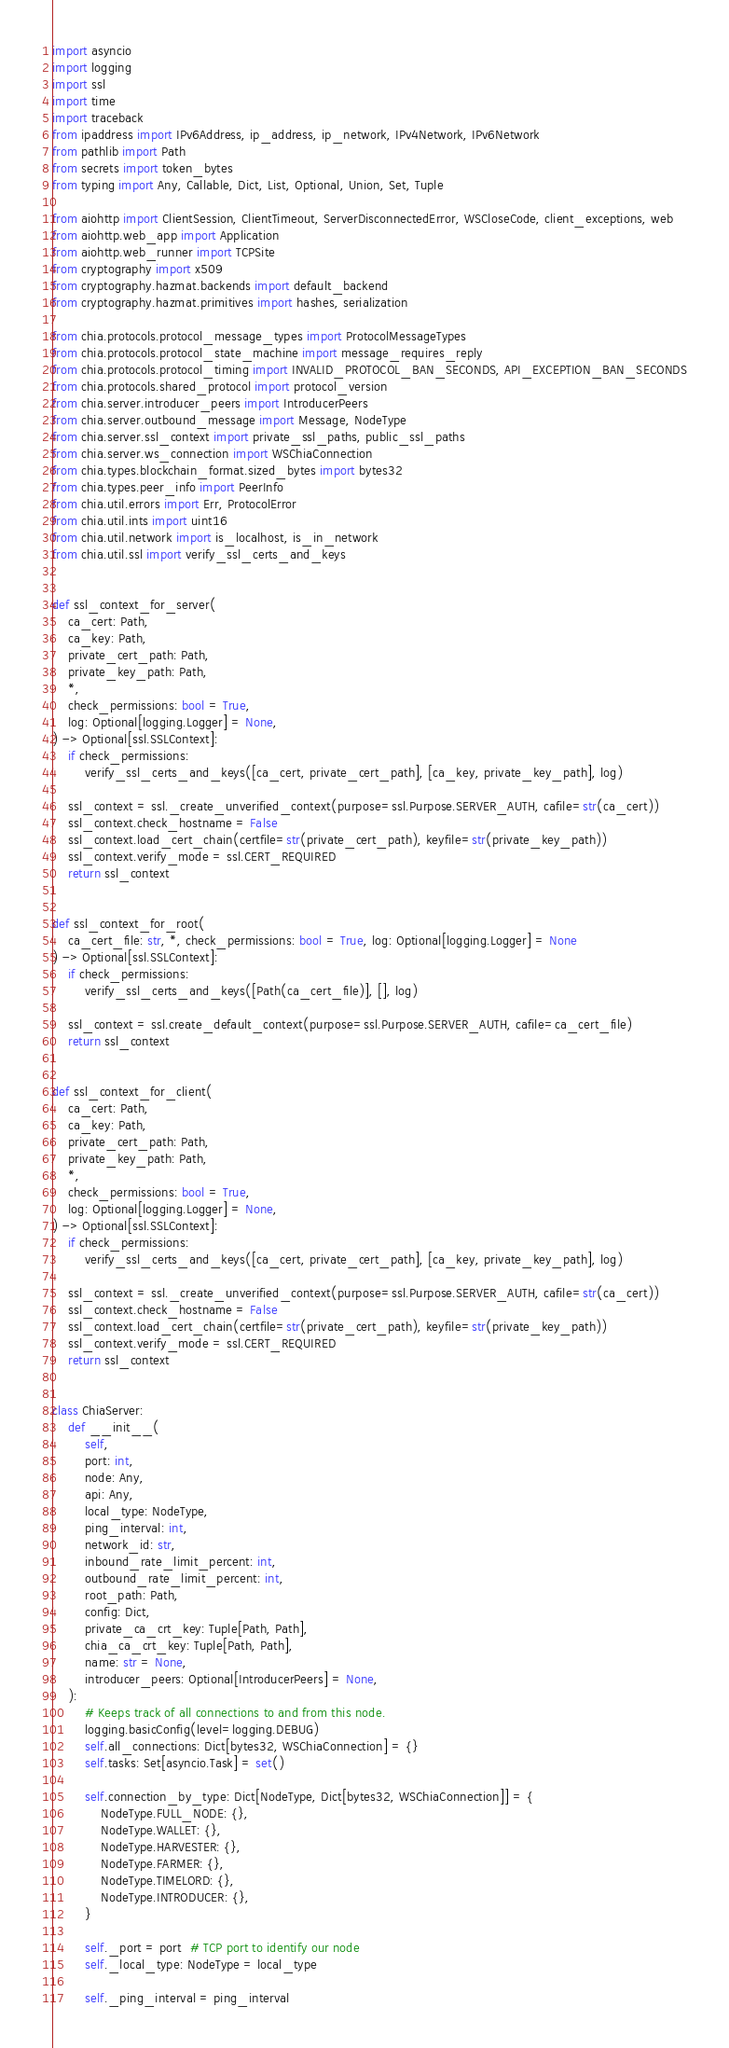<code> <loc_0><loc_0><loc_500><loc_500><_Python_>import asyncio
import logging
import ssl
import time
import traceback
from ipaddress import IPv6Address, ip_address, ip_network, IPv4Network, IPv6Network
from pathlib import Path
from secrets import token_bytes
from typing import Any, Callable, Dict, List, Optional, Union, Set, Tuple

from aiohttp import ClientSession, ClientTimeout, ServerDisconnectedError, WSCloseCode, client_exceptions, web
from aiohttp.web_app import Application
from aiohttp.web_runner import TCPSite
from cryptography import x509
from cryptography.hazmat.backends import default_backend
from cryptography.hazmat.primitives import hashes, serialization

from chia.protocols.protocol_message_types import ProtocolMessageTypes
from chia.protocols.protocol_state_machine import message_requires_reply
from chia.protocols.protocol_timing import INVALID_PROTOCOL_BAN_SECONDS, API_EXCEPTION_BAN_SECONDS
from chia.protocols.shared_protocol import protocol_version
from chia.server.introducer_peers import IntroducerPeers
from chia.server.outbound_message import Message, NodeType
from chia.server.ssl_context import private_ssl_paths, public_ssl_paths
from chia.server.ws_connection import WSChiaConnection
from chia.types.blockchain_format.sized_bytes import bytes32
from chia.types.peer_info import PeerInfo
from chia.util.errors import Err, ProtocolError
from chia.util.ints import uint16
from chia.util.network import is_localhost, is_in_network
from chia.util.ssl import verify_ssl_certs_and_keys


def ssl_context_for_server(
    ca_cert: Path,
    ca_key: Path,
    private_cert_path: Path,
    private_key_path: Path,
    *,
    check_permissions: bool = True,
    log: Optional[logging.Logger] = None,
) -> Optional[ssl.SSLContext]:
    if check_permissions:
        verify_ssl_certs_and_keys([ca_cert, private_cert_path], [ca_key, private_key_path], log)

    ssl_context = ssl._create_unverified_context(purpose=ssl.Purpose.SERVER_AUTH, cafile=str(ca_cert))
    ssl_context.check_hostname = False
    ssl_context.load_cert_chain(certfile=str(private_cert_path), keyfile=str(private_key_path))
    ssl_context.verify_mode = ssl.CERT_REQUIRED
    return ssl_context


def ssl_context_for_root(
    ca_cert_file: str, *, check_permissions: bool = True, log: Optional[logging.Logger] = None
) -> Optional[ssl.SSLContext]:
    if check_permissions:
        verify_ssl_certs_and_keys([Path(ca_cert_file)], [], log)

    ssl_context = ssl.create_default_context(purpose=ssl.Purpose.SERVER_AUTH, cafile=ca_cert_file)
    return ssl_context


def ssl_context_for_client(
    ca_cert: Path,
    ca_key: Path,
    private_cert_path: Path,
    private_key_path: Path,
    *,
    check_permissions: bool = True,
    log: Optional[logging.Logger] = None,
) -> Optional[ssl.SSLContext]:
    if check_permissions:
        verify_ssl_certs_and_keys([ca_cert, private_cert_path], [ca_key, private_key_path], log)

    ssl_context = ssl._create_unverified_context(purpose=ssl.Purpose.SERVER_AUTH, cafile=str(ca_cert))
    ssl_context.check_hostname = False
    ssl_context.load_cert_chain(certfile=str(private_cert_path), keyfile=str(private_key_path))
    ssl_context.verify_mode = ssl.CERT_REQUIRED
    return ssl_context


class ChiaServer:
    def __init__(
        self,
        port: int,
        node: Any,
        api: Any,
        local_type: NodeType,
        ping_interval: int,
        network_id: str,
        inbound_rate_limit_percent: int,
        outbound_rate_limit_percent: int,
        root_path: Path,
        config: Dict,
        private_ca_crt_key: Tuple[Path, Path],
        chia_ca_crt_key: Tuple[Path, Path],
        name: str = None,
        introducer_peers: Optional[IntroducerPeers] = None,
    ):
        # Keeps track of all connections to and from this node.
        logging.basicConfig(level=logging.DEBUG)
        self.all_connections: Dict[bytes32, WSChiaConnection] = {}
        self.tasks: Set[asyncio.Task] = set()

        self.connection_by_type: Dict[NodeType, Dict[bytes32, WSChiaConnection]] = {
            NodeType.FULL_NODE: {},
            NodeType.WALLET: {},
            NodeType.HARVESTER: {},
            NodeType.FARMER: {},
            NodeType.TIMELORD: {},
            NodeType.INTRODUCER: {},
        }

        self._port = port  # TCP port to identify our node
        self._local_type: NodeType = local_type

        self._ping_interval = ping_interval</code> 